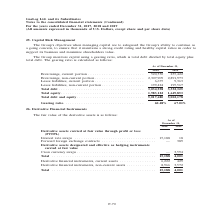According to Gaslog's financial document, How is gearing ratio calculated? total debt divided by total equity plus total debt. The document states: "monitors capital using a gearing ratio, which is total debt divided by total equity plus total debt. The gearing ratio is calculated as follows:..." Also, What is the Group's goal when managing capital? To safeguard the Group’s ability to continue as a going concern, to ensure that it maintains a strong credit rating and healthy capital ratios in order to support its business and maximize shareholders value.. The document states: "The Group’s objectives when managing capital are to safeguard the Group’s ability to continue as a going concern, to ensure that it maintains a strong..." Also, What are the components required to calculate gearing ratio? The document shows two values: Total debt and Total debt and equity. From the document: "Total debt and equity . 5,017,680 5,002,178 Total debt and equity . 5,017,680 5,002,178..." Additionally, Which year has a higher Total equity? According to the financial document, 2018. The relevant text states: "Continued) For the years ended December 31, 2017, 2018 and 2019 (All amounts expressed in thousands of U.S. Dollars, except share and per share data)..." Also, can you calculate: What was the change in gearing ratio from 2018 to 2019? Based on the calculation: 67.01% - 60.48% , the result is 6.53 (percentage). This is based on the information: "Gearing ratio . 60.48% 67.01% Gearing ratio . 60.48% 67.01%..." The key data points involved are: 60.48, 67.01. Also, can you calculate: What was the percentage change in total equity from 2018 to 2019? To answer this question, I need to perform calculations using the financial data. The calculation is: (1,649,853 - 1,983,122)/1,983,122 , which equals -16.81 (percentage). This is based on the information: "bt . 3,034,558 3,352,325 Total equity . 1,983,122 1,649,853 Total debt . 3,034,558 3,352,325 Total equity . 1,983,122 1,649,853..." The key data points involved are: 1,649,853, 1,983,122. 